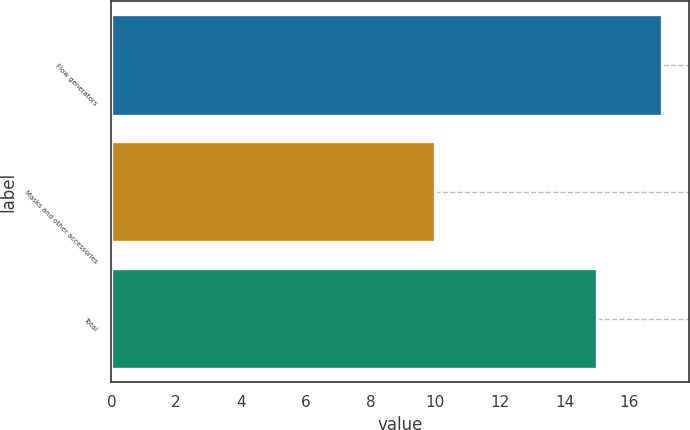<chart> <loc_0><loc_0><loc_500><loc_500><bar_chart><fcel>Flow generators<fcel>Masks and other accessories<fcel>Total<nl><fcel>17<fcel>10<fcel>15<nl></chart> 